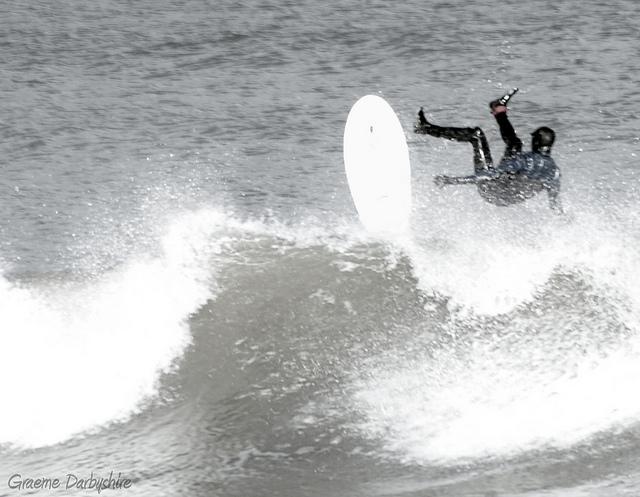Do you think this person is a good surfer?
Give a very brief answer. No. Are the waves calm?
Answer briefly. No. What color is the surfboard?
Short answer required. White. What color is the board this person fell off of?
Give a very brief answer. White. What is the man wearing?
Keep it brief. Wetsuit. 